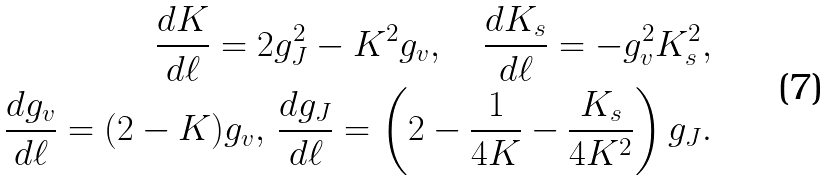Convert formula to latex. <formula><loc_0><loc_0><loc_500><loc_500>\frac { d K } { d \ell } = 2 g ^ { 2 } _ { J } - K ^ { 2 } g _ { v } , \quad \frac { d K _ { s } } { d \ell } = - g ^ { 2 } _ { v } K ^ { 2 } _ { s } , \\ \frac { d g _ { v } } { d \ell } = ( 2 - K ) g _ { v } , \, \frac { d g _ { J } } { d \ell } = \left ( 2 - \frac { 1 } { 4 K } - \frac { K _ { s } } { 4 K ^ { 2 } } \right ) g _ { J } .</formula> 